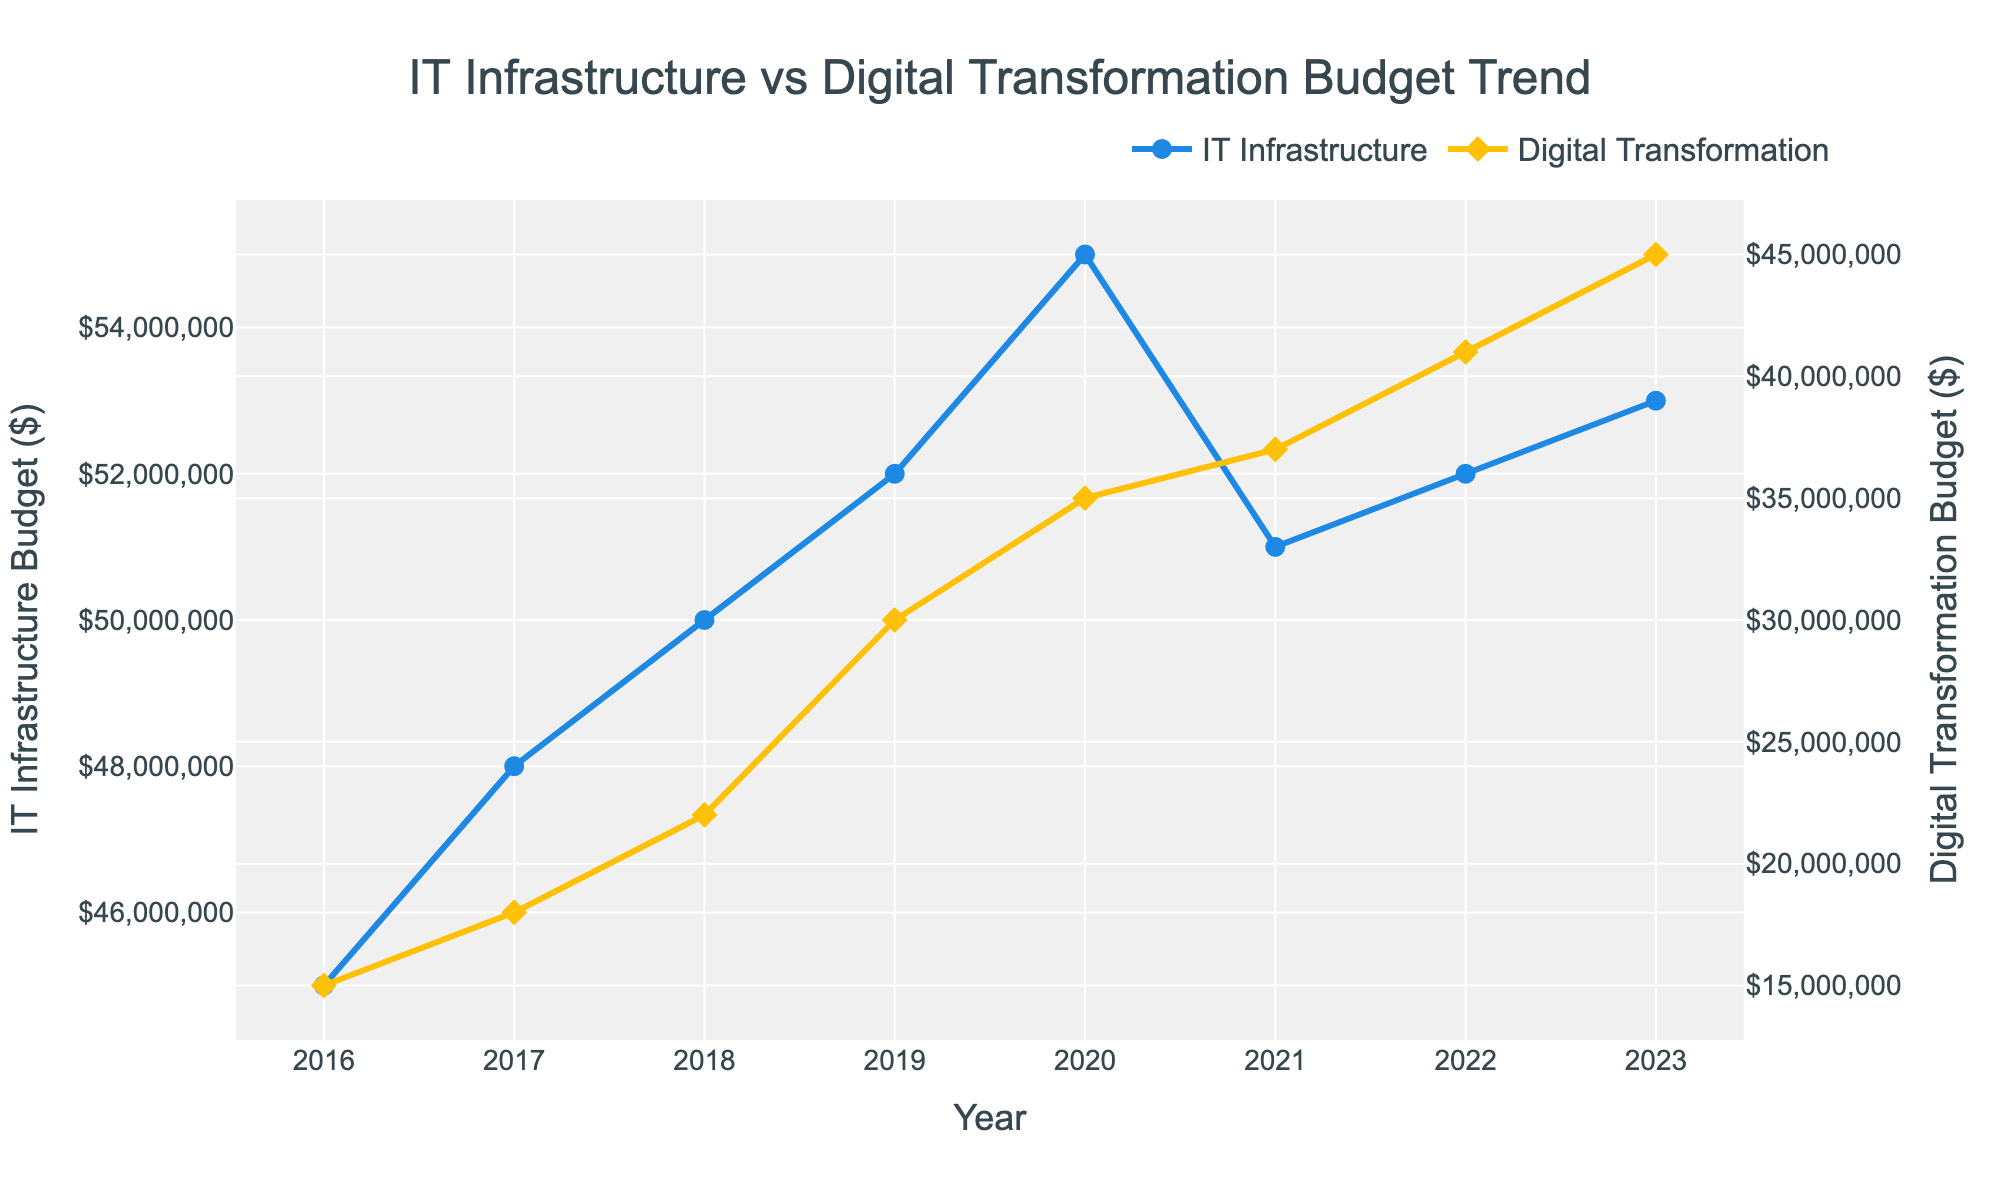What is the title of the figure? The title of the figure is displayed at the top of the plot. It reads "IT Infrastructure vs Digital Transformation Budget Trend".
Answer: IT Infrastructure vs Digital Transformation Budget Trend How many data points are there for each budget type? The data points are represented by markers on the lines. Each line has a pair of annual data points from 2016 to 2023, inclusive. Counting these gives 8 data points for each budget type.
Answer: 8 What is the highest budget amount allocated to Digital Transformation across the years? The markers show that the Digital Transformation budget peaks at the last data point in 2023. The value at this point is $45,000,000.
Answer: $45,000,000 In which year did the IT Infrastructure budget experience a decline compared to the previous year? Looking at the IT Infrastructure line, the budget decreased from 2020 ($55,000,000) to 2021 ($51,000,000).
Answer: 2021 How much did the Digital Transformation budget increase from 2022 to 2023? The Digital Transformation budget was $41,000,000 in 2022 and increased to $45,000,000 in 2023. The difference is $45,000,000 - $41,000,000 = $4,000,000.
Answer: $4,000,000 Which budget had a greater relative increase from 2016 to 2023? Calculate the percentage increase for both budgets from 2016 to 2023. The IT Infrastructure budget was $45,000,000 in 2016 and $53,000,000 in 2023, a 17.78% increase [(53 - 45)/45 * 100]. The Digital Transformation budget increased from $15,000,000 to $45,000,000, a 200% increase [(45 - 15)/15 * 100]. The Digital Transformation budget had a greater relative increase.
Answer: Digital Transformation budget What is the average IT Infrastructure budget between 2016 and 2023? Sum the yearly budgets: $45,000,000 + $48,000,000 + $50,000,000 + $52,000,000 + $55,000,000 + $51,000,000 + $52,000,000 + $53,000,000 = $406,000,000. Then divide by 8 (years): $406,000,000 / 8 = $50,750,000.
Answer: $50,750,000 Did the Digital Transformation budget ever exceed the IT Infrastructure budget? Comparing both lines, at no point does the Digital Transformation budget surpass the IT Infrastructure budget.
Answer: No What is the trend observed in the Digital Transformation budget from 2016 to 2023? The Digital Transformation budget shows a consistent upward trend from 2016 ($15,000,000) to 2023 ($45,000,000). The line steadily increases each year.
Answer: Consistent upward trend How does the rate of increase for IT Infrastructure and Digital Transformation budgets compare between 2016 and 2019? For IT Infrastructure: from $45,000,000 in 2016 to $52,000,000 in 2019 is an increase of $7,000,000 over 3 years. For Digital Transformation: from $15,000,000 in 2016 to $30,000,000 in 2019 is an increase of $15,000,000 over the same period. Hence, the rate of increase for the Digital Transformation budget is higher.
Answer: Digital Transformation rate is higher 